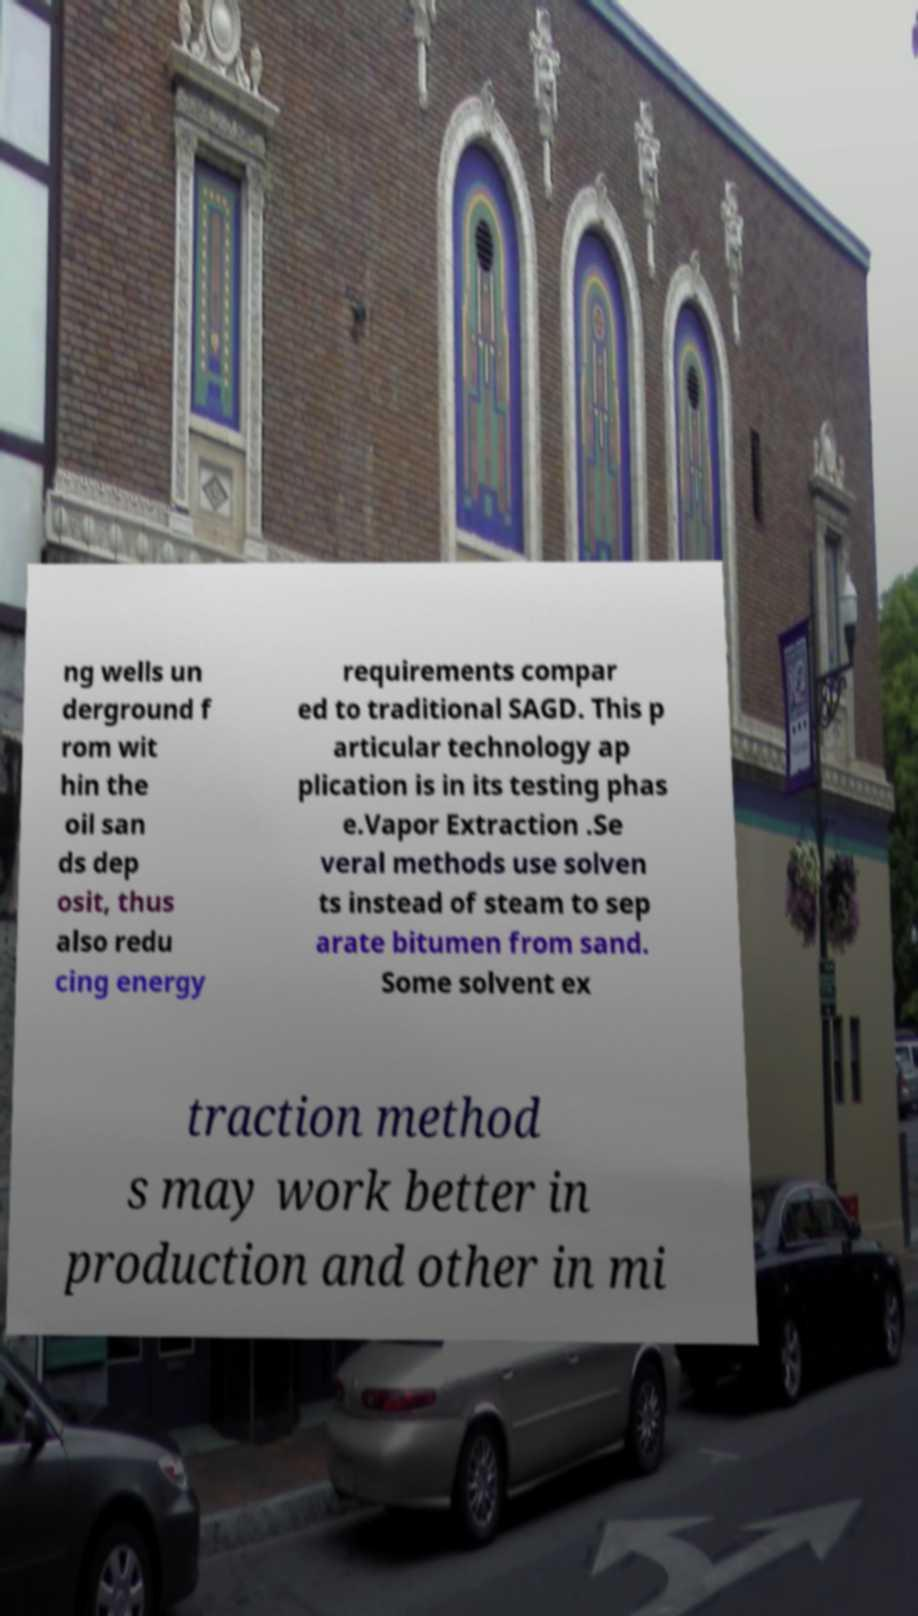What messages or text are displayed in this image? I need them in a readable, typed format. ng wells un derground f rom wit hin the oil san ds dep osit, thus also redu cing energy requirements compar ed to traditional SAGD. This p articular technology ap plication is in its testing phas e.Vapor Extraction .Se veral methods use solven ts instead of steam to sep arate bitumen from sand. Some solvent ex traction method s may work better in production and other in mi 